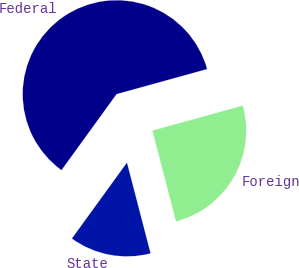Convert chart to OTSL. <chart><loc_0><loc_0><loc_500><loc_500><pie_chart><fcel>Federal<fcel>State<fcel>Foreign<nl><fcel>60.72%<fcel>14.03%<fcel>25.24%<nl></chart> 